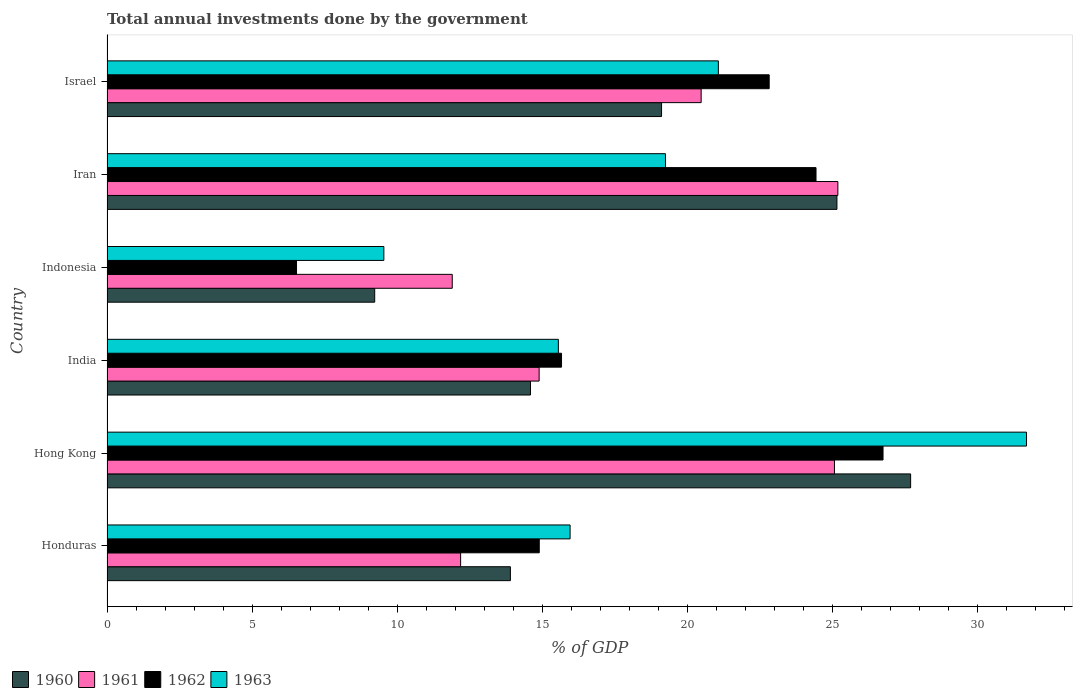Are the number of bars on each tick of the Y-axis equal?
Provide a succinct answer. Yes. What is the label of the 2nd group of bars from the top?
Provide a short and direct response. Iran. In how many cases, is the number of bars for a given country not equal to the number of legend labels?
Make the answer very short. 0. What is the total annual investments done by the government in 1960 in Hong Kong?
Offer a terse response. 27.69. Across all countries, what is the maximum total annual investments done by the government in 1962?
Offer a terse response. 26.74. Across all countries, what is the minimum total annual investments done by the government in 1961?
Provide a succinct answer. 11.9. In which country was the total annual investments done by the government in 1960 maximum?
Your response must be concise. Hong Kong. What is the total total annual investments done by the government in 1962 in the graph?
Keep it short and to the point. 111.07. What is the difference between the total annual investments done by the government in 1962 in Hong Kong and that in India?
Provide a short and direct response. 11.08. What is the difference between the total annual investments done by the government in 1963 in India and the total annual investments done by the government in 1960 in Honduras?
Your answer should be compact. 1.65. What is the average total annual investments done by the government in 1962 per country?
Give a very brief answer. 18.51. What is the difference between the total annual investments done by the government in 1962 and total annual investments done by the government in 1961 in Iran?
Your answer should be very brief. -0.75. What is the ratio of the total annual investments done by the government in 1960 in Honduras to that in Hong Kong?
Offer a terse response. 0.5. Is the total annual investments done by the government in 1960 in Honduras less than that in India?
Your answer should be compact. Yes. Is the difference between the total annual investments done by the government in 1962 in Honduras and India greater than the difference between the total annual investments done by the government in 1961 in Honduras and India?
Keep it short and to the point. Yes. What is the difference between the highest and the second highest total annual investments done by the government in 1961?
Ensure brevity in your answer.  0.12. What is the difference between the highest and the lowest total annual investments done by the government in 1963?
Give a very brief answer. 22.14. Is the sum of the total annual investments done by the government in 1960 in Honduras and India greater than the maximum total annual investments done by the government in 1962 across all countries?
Make the answer very short. Yes. Is it the case that in every country, the sum of the total annual investments done by the government in 1960 and total annual investments done by the government in 1961 is greater than the sum of total annual investments done by the government in 1963 and total annual investments done by the government in 1962?
Provide a succinct answer. No. How many bars are there?
Offer a terse response. 24. Does the graph contain any zero values?
Give a very brief answer. No. Does the graph contain grids?
Your response must be concise. No. How many legend labels are there?
Give a very brief answer. 4. How are the legend labels stacked?
Make the answer very short. Horizontal. What is the title of the graph?
Give a very brief answer. Total annual investments done by the government. Does "2007" appear as one of the legend labels in the graph?
Offer a terse response. No. What is the label or title of the X-axis?
Keep it short and to the point. % of GDP. What is the % of GDP of 1960 in Honduras?
Your answer should be very brief. 13.9. What is the % of GDP of 1961 in Honduras?
Make the answer very short. 12.18. What is the % of GDP of 1962 in Honduras?
Your answer should be compact. 14.89. What is the % of GDP in 1963 in Honduras?
Provide a short and direct response. 15.96. What is the % of GDP of 1960 in Hong Kong?
Keep it short and to the point. 27.69. What is the % of GDP of 1961 in Hong Kong?
Offer a very short reply. 25.06. What is the % of GDP in 1962 in Hong Kong?
Give a very brief answer. 26.74. What is the % of GDP in 1963 in Hong Kong?
Provide a succinct answer. 31.68. What is the % of GDP in 1960 in India?
Ensure brevity in your answer.  14.59. What is the % of GDP in 1961 in India?
Provide a short and direct response. 14.89. What is the % of GDP of 1962 in India?
Keep it short and to the point. 15.66. What is the % of GDP of 1963 in India?
Provide a succinct answer. 15.55. What is the % of GDP in 1960 in Indonesia?
Offer a terse response. 9.22. What is the % of GDP of 1961 in Indonesia?
Give a very brief answer. 11.9. What is the % of GDP of 1962 in Indonesia?
Offer a very short reply. 6.53. What is the % of GDP in 1963 in Indonesia?
Your response must be concise. 9.54. What is the % of GDP in 1960 in Iran?
Offer a very short reply. 25.15. What is the % of GDP of 1961 in Iran?
Provide a short and direct response. 25.18. What is the % of GDP in 1962 in Iran?
Your response must be concise. 24.43. What is the % of GDP of 1963 in Iran?
Your answer should be compact. 19.24. What is the % of GDP of 1960 in Israel?
Give a very brief answer. 19.11. What is the % of GDP in 1961 in Israel?
Keep it short and to the point. 20.47. What is the % of GDP in 1962 in Israel?
Offer a terse response. 22.82. What is the % of GDP of 1963 in Israel?
Give a very brief answer. 21.06. Across all countries, what is the maximum % of GDP of 1960?
Offer a terse response. 27.69. Across all countries, what is the maximum % of GDP of 1961?
Give a very brief answer. 25.18. Across all countries, what is the maximum % of GDP in 1962?
Your answer should be compact. 26.74. Across all countries, what is the maximum % of GDP in 1963?
Give a very brief answer. 31.68. Across all countries, what is the minimum % of GDP of 1960?
Offer a terse response. 9.22. Across all countries, what is the minimum % of GDP in 1961?
Offer a terse response. 11.9. Across all countries, what is the minimum % of GDP of 1962?
Provide a short and direct response. 6.53. Across all countries, what is the minimum % of GDP of 1963?
Give a very brief answer. 9.54. What is the total % of GDP of 1960 in the graph?
Offer a very short reply. 109.66. What is the total % of GDP of 1961 in the graph?
Offer a very short reply. 109.69. What is the total % of GDP in 1962 in the graph?
Provide a succinct answer. 111.07. What is the total % of GDP in 1963 in the graph?
Make the answer very short. 113.04. What is the difference between the % of GDP in 1960 in Honduras and that in Hong Kong?
Your answer should be compact. -13.79. What is the difference between the % of GDP of 1961 in Honduras and that in Hong Kong?
Keep it short and to the point. -12.88. What is the difference between the % of GDP in 1962 in Honduras and that in Hong Kong?
Offer a terse response. -11.84. What is the difference between the % of GDP in 1963 in Honduras and that in Hong Kong?
Provide a short and direct response. -15.73. What is the difference between the % of GDP of 1960 in Honduras and that in India?
Offer a terse response. -0.69. What is the difference between the % of GDP of 1961 in Honduras and that in India?
Your answer should be compact. -2.7. What is the difference between the % of GDP in 1962 in Honduras and that in India?
Provide a succinct answer. -0.77. What is the difference between the % of GDP in 1963 in Honduras and that in India?
Give a very brief answer. 0.4. What is the difference between the % of GDP of 1960 in Honduras and that in Indonesia?
Your answer should be very brief. 4.68. What is the difference between the % of GDP in 1961 in Honduras and that in Indonesia?
Ensure brevity in your answer.  0.29. What is the difference between the % of GDP in 1962 in Honduras and that in Indonesia?
Offer a very short reply. 8.36. What is the difference between the % of GDP of 1963 in Honduras and that in Indonesia?
Offer a terse response. 6.42. What is the difference between the % of GDP in 1960 in Honduras and that in Iran?
Your answer should be compact. -11.25. What is the difference between the % of GDP of 1961 in Honduras and that in Iran?
Make the answer very short. -13. What is the difference between the % of GDP of 1962 in Honduras and that in Iran?
Give a very brief answer. -9.54. What is the difference between the % of GDP in 1963 in Honduras and that in Iran?
Give a very brief answer. -3.29. What is the difference between the % of GDP of 1960 in Honduras and that in Israel?
Provide a succinct answer. -5.21. What is the difference between the % of GDP of 1961 in Honduras and that in Israel?
Provide a succinct answer. -8.29. What is the difference between the % of GDP of 1962 in Honduras and that in Israel?
Your answer should be very brief. -7.92. What is the difference between the % of GDP in 1963 in Honduras and that in Israel?
Your answer should be very brief. -5.11. What is the difference between the % of GDP in 1960 in Hong Kong and that in India?
Offer a terse response. 13.1. What is the difference between the % of GDP of 1961 in Hong Kong and that in India?
Your response must be concise. 10.18. What is the difference between the % of GDP in 1962 in Hong Kong and that in India?
Keep it short and to the point. 11.08. What is the difference between the % of GDP of 1963 in Hong Kong and that in India?
Offer a very short reply. 16.13. What is the difference between the % of GDP in 1960 in Hong Kong and that in Indonesia?
Your answer should be compact. 18.47. What is the difference between the % of GDP of 1961 in Hong Kong and that in Indonesia?
Your response must be concise. 13.17. What is the difference between the % of GDP in 1962 in Hong Kong and that in Indonesia?
Provide a short and direct response. 20.21. What is the difference between the % of GDP in 1963 in Hong Kong and that in Indonesia?
Give a very brief answer. 22.14. What is the difference between the % of GDP of 1960 in Hong Kong and that in Iran?
Your answer should be compact. 2.54. What is the difference between the % of GDP of 1961 in Hong Kong and that in Iran?
Ensure brevity in your answer.  -0.12. What is the difference between the % of GDP of 1962 in Hong Kong and that in Iran?
Make the answer very short. 2.31. What is the difference between the % of GDP of 1963 in Hong Kong and that in Iran?
Your response must be concise. 12.44. What is the difference between the % of GDP in 1960 in Hong Kong and that in Israel?
Provide a succinct answer. 8.58. What is the difference between the % of GDP of 1961 in Hong Kong and that in Israel?
Provide a succinct answer. 4.59. What is the difference between the % of GDP of 1962 in Hong Kong and that in Israel?
Offer a very short reply. 3.92. What is the difference between the % of GDP of 1963 in Hong Kong and that in Israel?
Your answer should be very brief. 10.62. What is the difference between the % of GDP in 1960 in India and that in Indonesia?
Give a very brief answer. 5.37. What is the difference between the % of GDP in 1961 in India and that in Indonesia?
Your response must be concise. 2.99. What is the difference between the % of GDP of 1962 in India and that in Indonesia?
Your answer should be very brief. 9.13. What is the difference between the % of GDP of 1963 in India and that in Indonesia?
Ensure brevity in your answer.  6.01. What is the difference between the % of GDP in 1960 in India and that in Iran?
Your answer should be compact. -10.56. What is the difference between the % of GDP of 1961 in India and that in Iran?
Offer a terse response. -10.29. What is the difference between the % of GDP in 1962 in India and that in Iran?
Make the answer very short. -8.77. What is the difference between the % of GDP of 1963 in India and that in Iran?
Your answer should be compact. -3.69. What is the difference between the % of GDP in 1960 in India and that in Israel?
Your response must be concise. -4.52. What is the difference between the % of GDP in 1961 in India and that in Israel?
Offer a very short reply. -5.58. What is the difference between the % of GDP in 1962 in India and that in Israel?
Your response must be concise. -7.15. What is the difference between the % of GDP of 1963 in India and that in Israel?
Your answer should be very brief. -5.51. What is the difference between the % of GDP in 1960 in Indonesia and that in Iran?
Ensure brevity in your answer.  -15.93. What is the difference between the % of GDP in 1961 in Indonesia and that in Iran?
Provide a succinct answer. -13.29. What is the difference between the % of GDP of 1962 in Indonesia and that in Iran?
Keep it short and to the point. -17.9. What is the difference between the % of GDP of 1963 in Indonesia and that in Iran?
Your answer should be compact. -9.7. What is the difference between the % of GDP in 1960 in Indonesia and that in Israel?
Give a very brief answer. -9.88. What is the difference between the % of GDP of 1961 in Indonesia and that in Israel?
Offer a terse response. -8.58. What is the difference between the % of GDP in 1962 in Indonesia and that in Israel?
Offer a very short reply. -16.29. What is the difference between the % of GDP in 1963 in Indonesia and that in Israel?
Provide a short and direct response. -11.53. What is the difference between the % of GDP of 1960 in Iran and that in Israel?
Ensure brevity in your answer.  6.04. What is the difference between the % of GDP in 1961 in Iran and that in Israel?
Your response must be concise. 4.71. What is the difference between the % of GDP in 1962 in Iran and that in Israel?
Provide a short and direct response. 1.61. What is the difference between the % of GDP of 1963 in Iran and that in Israel?
Ensure brevity in your answer.  -1.82. What is the difference between the % of GDP of 1960 in Honduras and the % of GDP of 1961 in Hong Kong?
Keep it short and to the point. -11.17. What is the difference between the % of GDP of 1960 in Honduras and the % of GDP of 1962 in Hong Kong?
Offer a very short reply. -12.84. What is the difference between the % of GDP of 1960 in Honduras and the % of GDP of 1963 in Hong Kong?
Offer a very short reply. -17.78. What is the difference between the % of GDP in 1961 in Honduras and the % of GDP in 1962 in Hong Kong?
Offer a very short reply. -14.55. What is the difference between the % of GDP in 1961 in Honduras and the % of GDP in 1963 in Hong Kong?
Provide a short and direct response. -19.5. What is the difference between the % of GDP in 1962 in Honduras and the % of GDP in 1963 in Hong Kong?
Your answer should be very brief. -16.79. What is the difference between the % of GDP of 1960 in Honduras and the % of GDP of 1961 in India?
Offer a terse response. -0.99. What is the difference between the % of GDP in 1960 in Honduras and the % of GDP in 1962 in India?
Your answer should be compact. -1.76. What is the difference between the % of GDP of 1960 in Honduras and the % of GDP of 1963 in India?
Your answer should be very brief. -1.65. What is the difference between the % of GDP in 1961 in Honduras and the % of GDP in 1962 in India?
Keep it short and to the point. -3.48. What is the difference between the % of GDP in 1961 in Honduras and the % of GDP in 1963 in India?
Offer a terse response. -3.37. What is the difference between the % of GDP of 1962 in Honduras and the % of GDP of 1963 in India?
Offer a very short reply. -0.66. What is the difference between the % of GDP of 1960 in Honduras and the % of GDP of 1961 in Indonesia?
Provide a short and direct response. 2. What is the difference between the % of GDP in 1960 in Honduras and the % of GDP in 1962 in Indonesia?
Offer a terse response. 7.37. What is the difference between the % of GDP of 1960 in Honduras and the % of GDP of 1963 in Indonesia?
Offer a terse response. 4.36. What is the difference between the % of GDP of 1961 in Honduras and the % of GDP of 1962 in Indonesia?
Your answer should be very brief. 5.65. What is the difference between the % of GDP of 1961 in Honduras and the % of GDP of 1963 in Indonesia?
Make the answer very short. 2.64. What is the difference between the % of GDP in 1962 in Honduras and the % of GDP in 1963 in Indonesia?
Your answer should be very brief. 5.35. What is the difference between the % of GDP in 1960 in Honduras and the % of GDP in 1961 in Iran?
Provide a short and direct response. -11.28. What is the difference between the % of GDP of 1960 in Honduras and the % of GDP of 1962 in Iran?
Your answer should be very brief. -10.53. What is the difference between the % of GDP of 1960 in Honduras and the % of GDP of 1963 in Iran?
Provide a short and direct response. -5.34. What is the difference between the % of GDP in 1961 in Honduras and the % of GDP in 1962 in Iran?
Offer a terse response. -12.24. What is the difference between the % of GDP in 1961 in Honduras and the % of GDP in 1963 in Iran?
Offer a terse response. -7.06. What is the difference between the % of GDP of 1962 in Honduras and the % of GDP of 1963 in Iran?
Keep it short and to the point. -4.35. What is the difference between the % of GDP of 1960 in Honduras and the % of GDP of 1961 in Israel?
Your answer should be very brief. -6.57. What is the difference between the % of GDP in 1960 in Honduras and the % of GDP in 1962 in Israel?
Offer a terse response. -8.92. What is the difference between the % of GDP in 1960 in Honduras and the % of GDP in 1963 in Israel?
Ensure brevity in your answer.  -7.17. What is the difference between the % of GDP of 1961 in Honduras and the % of GDP of 1962 in Israel?
Provide a succinct answer. -10.63. What is the difference between the % of GDP of 1961 in Honduras and the % of GDP of 1963 in Israel?
Make the answer very short. -8.88. What is the difference between the % of GDP in 1962 in Honduras and the % of GDP in 1963 in Israel?
Give a very brief answer. -6.17. What is the difference between the % of GDP of 1960 in Hong Kong and the % of GDP of 1961 in India?
Give a very brief answer. 12.8. What is the difference between the % of GDP in 1960 in Hong Kong and the % of GDP in 1962 in India?
Your answer should be very brief. 12.03. What is the difference between the % of GDP in 1960 in Hong Kong and the % of GDP in 1963 in India?
Offer a terse response. 12.14. What is the difference between the % of GDP in 1961 in Hong Kong and the % of GDP in 1962 in India?
Your answer should be very brief. 9.4. What is the difference between the % of GDP of 1961 in Hong Kong and the % of GDP of 1963 in India?
Make the answer very short. 9.51. What is the difference between the % of GDP of 1962 in Hong Kong and the % of GDP of 1963 in India?
Provide a short and direct response. 11.19. What is the difference between the % of GDP of 1960 in Hong Kong and the % of GDP of 1961 in Indonesia?
Provide a succinct answer. 15.79. What is the difference between the % of GDP in 1960 in Hong Kong and the % of GDP in 1962 in Indonesia?
Provide a short and direct response. 21.16. What is the difference between the % of GDP in 1960 in Hong Kong and the % of GDP in 1963 in Indonesia?
Your answer should be compact. 18.15. What is the difference between the % of GDP of 1961 in Hong Kong and the % of GDP of 1962 in Indonesia?
Your response must be concise. 18.54. What is the difference between the % of GDP of 1961 in Hong Kong and the % of GDP of 1963 in Indonesia?
Give a very brief answer. 15.53. What is the difference between the % of GDP in 1962 in Hong Kong and the % of GDP in 1963 in Indonesia?
Offer a terse response. 17.2. What is the difference between the % of GDP in 1960 in Hong Kong and the % of GDP in 1961 in Iran?
Your response must be concise. 2.51. What is the difference between the % of GDP in 1960 in Hong Kong and the % of GDP in 1962 in Iran?
Provide a succinct answer. 3.26. What is the difference between the % of GDP of 1960 in Hong Kong and the % of GDP of 1963 in Iran?
Offer a terse response. 8.45. What is the difference between the % of GDP of 1961 in Hong Kong and the % of GDP of 1962 in Iran?
Make the answer very short. 0.64. What is the difference between the % of GDP of 1961 in Hong Kong and the % of GDP of 1963 in Iran?
Give a very brief answer. 5.82. What is the difference between the % of GDP in 1962 in Hong Kong and the % of GDP in 1963 in Iran?
Offer a terse response. 7.5. What is the difference between the % of GDP of 1960 in Hong Kong and the % of GDP of 1961 in Israel?
Offer a very short reply. 7.22. What is the difference between the % of GDP of 1960 in Hong Kong and the % of GDP of 1962 in Israel?
Provide a succinct answer. 4.87. What is the difference between the % of GDP of 1960 in Hong Kong and the % of GDP of 1963 in Israel?
Make the answer very short. 6.62. What is the difference between the % of GDP of 1961 in Hong Kong and the % of GDP of 1962 in Israel?
Your answer should be very brief. 2.25. What is the difference between the % of GDP of 1961 in Hong Kong and the % of GDP of 1963 in Israel?
Give a very brief answer. 4. What is the difference between the % of GDP of 1962 in Hong Kong and the % of GDP of 1963 in Israel?
Make the answer very short. 5.67. What is the difference between the % of GDP in 1960 in India and the % of GDP in 1961 in Indonesia?
Your response must be concise. 2.7. What is the difference between the % of GDP in 1960 in India and the % of GDP in 1962 in Indonesia?
Keep it short and to the point. 8.06. What is the difference between the % of GDP of 1960 in India and the % of GDP of 1963 in Indonesia?
Provide a short and direct response. 5.05. What is the difference between the % of GDP of 1961 in India and the % of GDP of 1962 in Indonesia?
Offer a terse response. 8.36. What is the difference between the % of GDP of 1961 in India and the % of GDP of 1963 in Indonesia?
Your response must be concise. 5.35. What is the difference between the % of GDP of 1962 in India and the % of GDP of 1963 in Indonesia?
Your answer should be compact. 6.12. What is the difference between the % of GDP of 1960 in India and the % of GDP of 1961 in Iran?
Provide a succinct answer. -10.59. What is the difference between the % of GDP of 1960 in India and the % of GDP of 1962 in Iran?
Provide a short and direct response. -9.84. What is the difference between the % of GDP of 1960 in India and the % of GDP of 1963 in Iran?
Ensure brevity in your answer.  -4.65. What is the difference between the % of GDP of 1961 in India and the % of GDP of 1962 in Iran?
Provide a short and direct response. -9.54. What is the difference between the % of GDP in 1961 in India and the % of GDP in 1963 in Iran?
Offer a terse response. -4.35. What is the difference between the % of GDP of 1962 in India and the % of GDP of 1963 in Iran?
Your answer should be very brief. -3.58. What is the difference between the % of GDP in 1960 in India and the % of GDP in 1961 in Israel?
Offer a terse response. -5.88. What is the difference between the % of GDP in 1960 in India and the % of GDP in 1962 in Israel?
Offer a terse response. -8.22. What is the difference between the % of GDP of 1960 in India and the % of GDP of 1963 in Israel?
Give a very brief answer. -6.47. What is the difference between the % of GDP of 1961 in India and the % of GDP of 1962 in Israel?
Give a very brief answer. -7.93. What is the difference between the % of GDP of 1961 in India and the % of GDP of 1963 in Israel?
Ensure brevity in your answer.  -6.18. What is the difference between the % of GDP in 1962 in India and the % of GDP in 1963 in Israel?
Provide a short and direct response. -5.4. What is the difference between the % of GDP of 1960 in Indonesia and the % of GDP of 1961 in Iran?
Ensure brevity in your answer.  -15.96. What is the difference between the % of GDP of 1960 in Indonesia and the % of GDP of 1962 in Iran?
Provide a succinct answer. -15.21. What is the difference between the % of GDP in 1960 in Indonesia and the % of GDP in 1963 in Iran?
Your answer should be very brief. -10.02. What is the difference between the % of GDP of 1961 in Indonesia and the % of GDP of 1962 in Iran?
Ensure brevity in your answer.  -12.53. What is the difference between the % of GDP in 1961 in Indonesia and the % of GDP in 1963 in Iran?
Offer a very short reply. -7.35. What is the difference between the % of GDP in 1962 in Indonesia and the % of GDP in 1963 in Iran?
Ensure brevity in your answer.  -12.71. What is the difference between the % of GDP of 1960 in Indonesia and the % of GDP of 1961 in Israel?
Your response must be concise. -11.25. What is the difference between the % of GDP in 1960 in Indonesia and the % of GDP in 1962 in Israel?
Your response must be concise. -13.59. What is the difference between the % of GDP of 1960 in Indonesia and the % of GDP of 1963 in Israel?
Provide a succinct answer. -11.84. What is the difference between the % of GDP in 1961 in Indonesia and the % of GDP in 1962 in Israel?
Offer a terse response. -10.92. What is the difference between the % of GDP in 1961 in Indonesia and the % of GDP in 1963 in Israel?
Offer a terse response. -9.17. What is the difference between the % of GDP of 1962 in Indonesia and the % of GDP of 1963 in Israel?
Keep it short and to the point. -14.54. What is the difference between the % of GDP of 1960 in Iran and the % of GDP of 1961 in Israel?
Your response must be concise. 4.68. What is the difference between the % of GDP of 1960 in Iran and the % of GDP of 1962 in Israel?
Your response must be concise. 2.33. What is the difference between the % of GDP in 1960 in Iran and the % of GDP in 1963 in Israel?
Make the answer very short. 4.08. What is the difference between the % of GDP of 1961 in Iran and the % of GDP of 1962 in Israel?
Your answer should be compact. 2.37. What is the difference between the % of GDP of 1961 in Iran and the % of GDP of 1963 in Israel?
Ensure brevity in your answer.  4.12. What is the difference between the % of GDP of 1962 in Iran and the % of GDP of 1963 in Israel?
Provide a short and direct response. 3.36. What is the average % of GDP of 1960 per country?
Offer a terse response. 18.28. What is the average % of GDP of 1961 per country?
Keep it short and to the point. 18.28. What is the average % of GDP in 1962 per country?
Ensure brevity in your answer.  18.51. What is the average % of GDP in 1963 per country?
Ensure brevity in your answer.  18.84. What is the difference between the % of GDP of 1960 and % of GDP of 1961 in Honduras?
Your answer should be compact. 1.71. What is the difference between the % of GDP in 1960 and % of GDP in 1962 in Honduras?
Make the answer very short. -1. What is the difference between the % of GDP of 1960 and % of GDP of 1963 in Honduras?
Provide a succinct answer. -2.06. What is the difference between the % of GDP in 1961 and % of GDP in 1962 in Honduras?
Your answer should be compact. -2.71. What is the difference between the % of GDP in 1961 and % of GDP in 1963 in Honduras?
Provide a succinct answer. -3.77. What is the difference between the % of GDP of 1962 and % of GDP of 1963 in Honduras?
Your response must be concise. -1.06. What is the difference between the % of GDP in 1960 and % of GDP in 1961 in Hong Kong?
Provide a succinct answer. 2.62. What is the difference between the % of GDP of 1960 and % of GDP of 1962 in Hong Kong?
Provide a succinct answer. 0.95. What is the difference between the % of GDP of 1960 and % of GDP of 1963 in Hong Kong?
Make the answer very short. -3.99. What is the difference between the % of GDP of 1961 and % of GDP of 1962 in Hong Kong?
Provide a short and direct response. -1.67. What is the difference between the % of GDP of 1961 and % of GDP of 1963 in Hong Kong?
Your response must be concise. -6.62. What is the difference between the % of GDP of 1962 and % of GDP of 1963 in Hong Kong?
Provide a short and direct response. -4.94. What is the difference between the % of GDP of 1960 and % of GDP of 1961 in India?
Offer a terse response. -0.3. What is the difference between the % of GDP in 1960 and % of GDP in 1962 in India?
Your answer should be compact. -1.07. What is the difference between the % of GDP in 1960 and % of GDP in 1963 in India?
Keep it short and to the point. -0.96. What is the difference between the % of GDP in 1961 and % of GDP in 1962 in India?
Provide a short and direct response. -0.77. What is the difference between the % of GDP in 1961 and % of GDP in 1963 in India?
Your response must be concise. -0.66. What is the difference between the % of GDP of 1962 and % of GDP of 1963 in India?
Offer a terse response. 0.11. What is the difference between the % of GDP in 1960 and % of GDP in 1961 in Indonesia?
Your answer should be very brief. -2.67. What is the difference between the % of GDP of 1960 and % of GDP of 1962 in Indonesia?
Make the answer very short. 2.69. What is the difference between the % of GDP in 1960 and % of GDP in 1963 in Indonesia?
Your answer should be very brief. -0.32. What is the difference between the % of GDP of 1961 and % of GDP of 1962 in Indonesia?
Offer a terse response. 5.37. What is the difference between the % of GDP of 1961 and % of GDP of 1963 in Indonesia?
Your answer should be compact. 2.36. What is the difference between the % of GDP in 1962 and % of GDP in 1963 in Indonesia?
Your answer should be very brief. -3.01. What is the difference between the % of GDP in 1960 and % of GDP in 1961 in Iran?
Provide a short and direct response. -0.03. What is the difference between the % of GDP in 1960 and % of GDP in 1962 in Iran?
Offer a very short reply. 0.72. What is the difference between the % of GDP in 1960 and % of GDP in 1963 in Iran?
Give a very brief answer. 5.91. What is the difference between the % of GDP in 1961 and % of GDP in 1962 in Iran?
Give a very brief answer. 0.75. What is the difference between the % of GDP in 1961 and % of GDP in 1963 in Iran?
Ensure brevity in your answer.  5.94. What is the difference between the % of GDP of 1962 and % of GDP of 1963 in Iran?
Your response must be concise. 5.19. What is the difference between the % of GDP of 1960 and % of GDP of 1961 in Israel?
Your answer should be compact. -1.36. What is the difference between the % of GDP of 1960 and % of GDP of 1962 in Israel?
Your response must be concise. -3.71. What is the difference between the % of GDP of 1960 and % of GDP of 1963 in Israel?
Your answer should be very brief. -1.96. What is the difference between the % of GDP in 1961 and % of GDP in 1962 in Israel?
Offer a very short reply. -2.34. What is the difference between the % of GDP in 1961 and % of GDP in 1963 in Israel?
Keep it short and to the point. -0.59. What is the difference between the % of GDP in 1962 and % of GDP in 1963 in Israel?
Your answer should be very brief. 1.75. What is the ratio of the % of GDP of 1960 in Honduras to that in Hong Kong?
Offer a very short reply. 0.5. What is the ratio of the % of GDP of 1961 in Honduras to that in Hong Kong?
Provide a succinct answer. 0.49. What is the ratio of the % of GDP in 1962 in Honduras to that in Hong Kong?
Offer a terse response. 0.56. What is the ratio of the % of GDP in 1963 in Honduras to that in Hong Kong?
Offer a terse response. 0.5. What is the ratio of the % of GDP of 1960 in Honduras to that in India?
Your answer should be compact. 0.95. What is the ratio of the % of GDP of 1961 in Honduras to that in India?
Offer a very short reply. 0.82. What is the ratio of the % of GDP of 1962 in Honduras to that in India?
Offer a terse response. 0.95. What is the ratio of the % of GDP of 1960 in Honduras to that in Indonesia?
Keep it short and to the point. 1.51. What is the ratio of the % of GDP of 1961 in Honduras to that in Indonesia?
Provide a succinct answer. 1.02. What is the ratio of the % of GDP of 1962 in Honduras to that in Indonesia?
Give a very brief answer. 2.28. What is the ratio of the % of GDP in 1963 in Honduras to that in Indonesia?
Give a very brief answer. 1.67. What is the ratio of the % of GDP of 1960 in Honduras to that in Iran?
Your response must be concise. 0.55. What is the ratio of the % of GDP of 1961 in Honduras to that in Iran?
Your answer should be compact. 0.48. What is the ratio of the % of GDP in 1962 in Honduras to that in Iran?
Offer a terse response. 0.61. What is the ratio of the % of GDP in 1963 in Honduras to that in Iran?
Your answer should be very brief. 0.83. What is the ratio of the % of GDP of 1960 in Honduras to that in Israel?
Give a very brief answer. 0.73. What is the ratio of the % of GDP in 1961 in Honduras to that in Israel?
Offer a terse response. 0.6. What is the ratio of the % of GDP in 1962 in Honduras to that in Israel?
Provide a succinct answer. 0.65. What is the ratio of the % of GDP in 1963 in Honduras to that in Israel?
Provide a succinct answer. 0.76. What is the ratio of the % of GDP of 1960 in Hong Kong to that in India?
Offer a terse response. 1.9. What is the ratio of the % of GDP of 1961 in Hong Kong to that in India?
Offer a very short reply. 1.68. What is the ratio of the % of GDP of 1962 in Hong Kong to that in India?
Ensure brevity in your answer.  1.71. What is the ratio of the % of GDP in 1963 in Hong Kong to that in India?
Offer a very short reply. 2.04. What is the ratio of the % of GDP of 1960 in Hong Kong to that in Indonesia?
Give a very brief answer. 3. What is the ratio of the % of GDP of 1961 in Hong Kong to that in Indonesia?
Offer a very short reply. 2.11. What is the ratio of the % of GDP of 1962 in Hong Kong to that in Indonesia?
Give a very brief answer. 4.09. What is the ratio of the % of GDP in 1963 in Hong Kong to that in Indonesia?
Make the answer very short. 3.32. What is the ratio of the % of GDP of 1960 in Hong Kong to that in Iran?
Offer a terse response. 1.1. What is the ratio of the % of GDP of 1962 in Hong Kong to that in Iran?
Provide a succinct answer. 1.09. What is the ratio of the % of GDP in 1963 in Hong Kong to that in Iran?
Provide a short and direct response. 1.65. What is the ratio of the % of GDP in 1960 in Hong Kong to that in Israel?
Keep it short and to the point. 1.45. What is the ratio of the % of GDP of 1961 in Hong Kong to that in Israel?
Keep it short and to the point. 1.22. What is the ratio of the % of GDP of 1962 in Hong Kong to that in Israel?
Your answer should be compact. 1.17. What is the ratio of the % of GDP in 1963 in Hong Kong to that in Israel?
Provide a short and direct response. 1.5. What is the ratio of the % of GDP in 1960 in India to that in Indonesia?
Offer a very short reply. 1.58. What is the ratio of the % of GDP in 1961 in India to that in Indonesia?
Give a very brief answer. 1.25. What is the ratio of the % of GDP in 1962 in India to that in Indonesia?
Offer a very short reply. 2.4. What is the ratio of the % of GDP in 1963 in India to that in Indonesia?
Give a very brief answer. 1.63. What is the ratio of the % of GDP in 1960 in India to that in Iran?
Provide a short and direct response. 0.58. What is the ratio of the % of GDP of 1961 in India to that in Iran?
Provide a succinct answer. 0.59. What is the ratio of the % of GDP in 1962 in India to that in Iran?
Your answer should be very brief. 0.64. What is the ratio of the % of GDP in 1963 in India to that in Iran?
Give a very brief answer. 0.81. What is the ratio of the % of GDP of 1960 in India to that in Israel?
Make the answer very short. 0.76. What is the ratio of the % of GDP of 1961 in India to that in Israel?
Your answer should be very brief. 0.73. What is the ratio of the % of GDP of 1962 in India to that in Israel?
Provide a succinct answer. 0.69. What is the ratio of the % of GDP of 1963 in India to that in Israel?
Offer a terse response. 0.74. What is the ratio of the % of GDP of 1960 in Indonesia to that in Iran?
Provide a succinct answer. 0.37. What is the ratio of the % of GDP in 1961 in Indonesia to that in Iran?
Offer a very short reply. 0.47. What is the ratio of the % of GDP of 1962 in Indonesia to that in Iran?
Give a very brief answer. 0.27. What is the ratio of the % of GDP of 1963 in Indonesia to that in Iran?
Keep it short and to the point. 0.5. What is the ratio of the % of GDP in 1960 in Indonesia to that in Israel?
Keep it short and to the point. 0.48. What is the ratio of the % of GDP of 1961 in Indonesia to that in Israel?
Provide a short and direct response. 0.58. What is the ratio of the % of GDP of 1962 in Indonesia to that in Israel?
Keep it short and to the point. 0.29. What is the ratio of the % of GDP in 1963 in Indonesia to that in Israel?
Your response must be concise. 0.45. What is the ratio of the % of GDP of 1960 in Iran to that in Israel?
Ensure brevity in your answer.  1.32. What is the ratio of the % of GDP of 1961 in Iran to that in Israel?
Offer a very short reply. 1.23. What is the ratio of the % of GDP in 1962 in Iran to that in Israel?
Your answer should be compact. 1.07. What is the ratio of the % of GDP of 1963 in Iran to that in Israel?
Provide a succinct answer. 0.91. What is the difference between the highest and the second highest % of GDP of 1960?
Make the answer very short. 2.54. What is the difference between the highest and the second highest % of GDP of 1961?
Make the answer very short. 0.12. What is the difference between the highest and the second highest % of GDP in 1962?
Provide a succinct answer. 2.31. What is the difference between the highest and the second highest % of GDP in 1963?
Give a very brief answer. 10.62. What is the difference between the highest and the lowest % of GDP in 1960?
Provide a short and direct response. 18.47. What is the difference between the highest and the lowest % of GDP in 1961?
Your answer should be very brief. 13.29. What is the difference between the highest and the lowest % of GDP in 1962?
Keep it short and to the point. 20.21. What is the difference between the highest and the lowest % of GDP in 1963?
Your answer should be very brief. 22.14. 